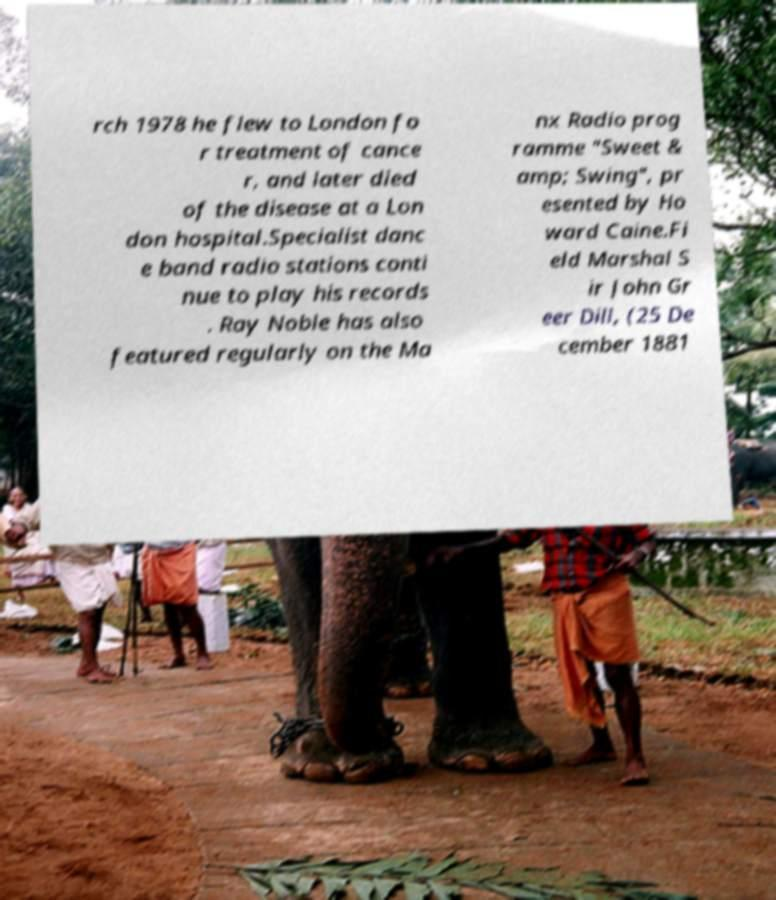There's text embedded in this image that I need extracted. Can you transcribe it verbatim? rch 1978 he flew to London fo r treatment of cance r, and later died of the disease at a Lon don hospital.Specialist danc e band radio stations conti nue to play his records . Ray Noble has also featured regularly on the Ma nx Radio prog ramme "Sweet & amp; Swing", pr esented by Ho ward Caine.Fi eld Marshal S ir John Gr eer Dill, (25 De cember 1881 